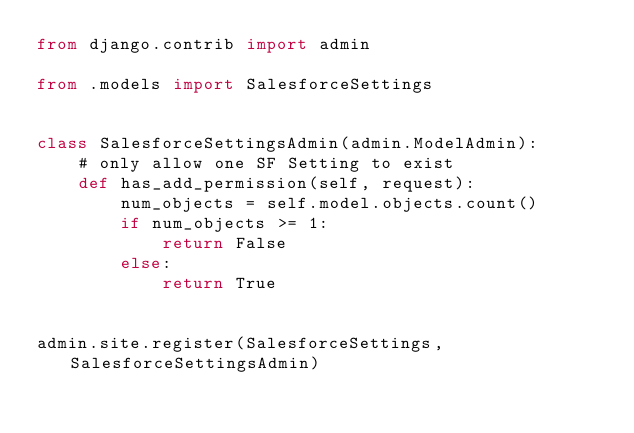<code> <loc_0><loc_0><loc_500><loc_500><_Python_>from django.contrib import admin

from .models import SalesforceSettings


class SalesforceSettingsAdmin(admin.ModelAdmin):
    # only allow one SF Setting to exist
    def has_add_permission(self, request):
        num_objects = self.model.objects.count()
        if num_objects >= 1:
            return False
        else:
            return True


admin.site.register(SalesforceSettings, SalesforceSettingsAdmin)
</code> 